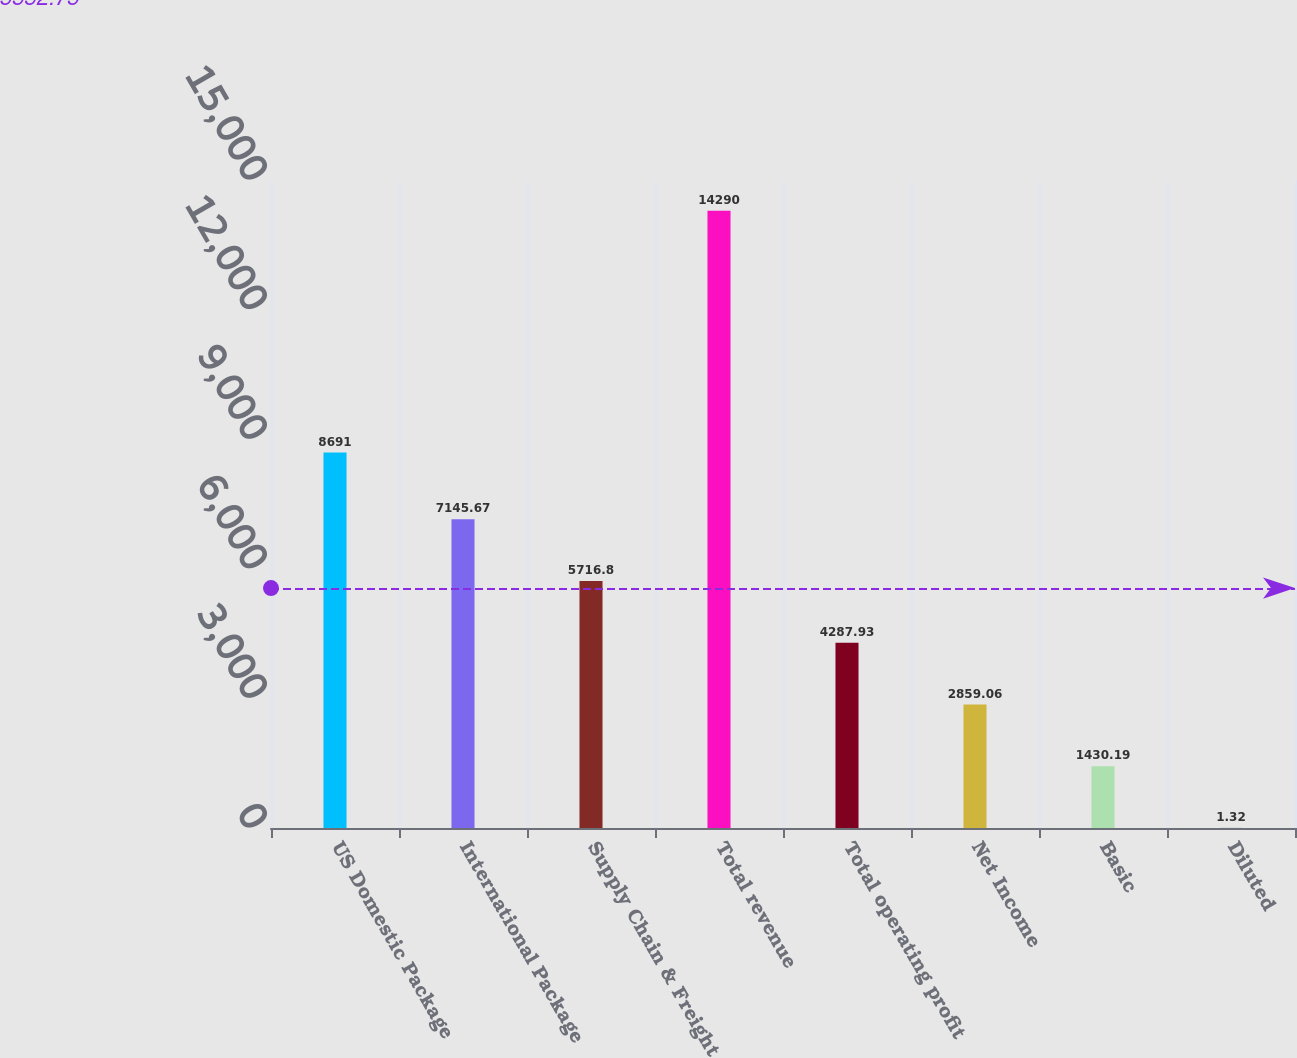Convert chart. <chart><loc_0><loc_0><loc_500><loc_500><bar_chart><fcel>US Domestic Package<fcel>International Package<fcel>Supply Chain & Freight<fcel>Total revenue<fcel>Total operating profit<fcel>Net Income<fcel>Basic<fcel>Diluted<nl><fcel>8691<fcel>7145.67<fcel>5716.8<fcel>14290<fcel>4287.93<fcel>2859.06<fcel>1430.19<fcel>1.32<nl></chart> 